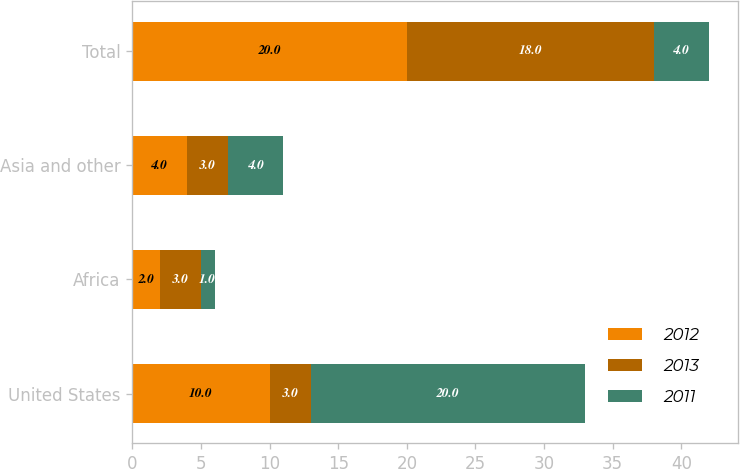<chart> <loc_0><loc_0><loc_500><loc_500><stacked_bar_chart><ecel><fcel>United States<fcel>Africa<fcel>Asia and other<fcel>Total<nl><fcel>2012<fcel>10<fcel>2<fcel>4<fcel>20<nl><fcel>2013<fcel>3<fcel>3<fcel>3<fcel>18<nl><fcel>2011<fcel>20<fcel>1<fcel>4<fcel>4<nl></chart> 